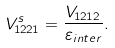<formula> <loc_0><loc_0><loc_500><loc_500>V _ { 1 2 2 1 } ^ { s } = \frac { V _ { 1 2 1 2 } } { \varepsilon _ { i n t e r } } .</formula> 